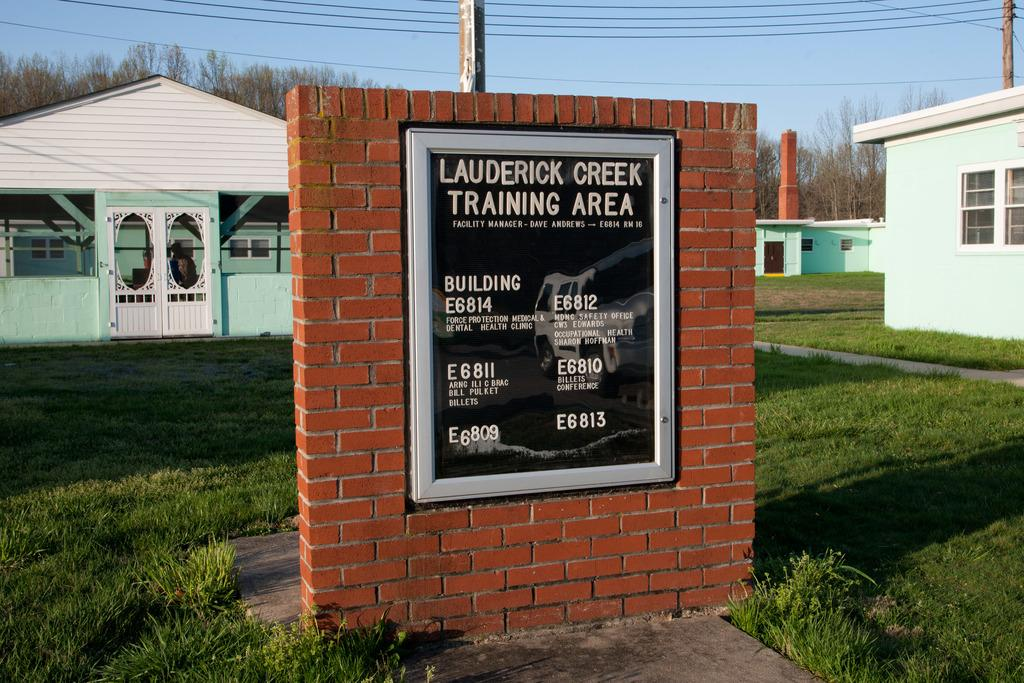What type of structure is present in the image? There is a brick wall in the image. What is attached to the brick wall? There is a frame attached to the brick wall. What type of buildings can be seen in the image? There are houses visible in the image. What type of vegetation is present in the image? There is a tree, plants, and grass visible in the image. Who is the creator of the cannon visible in the image? There is no cannon present in the image. What type of plough is being used to cultivate the grass in the image? There is no plough visible in the image; it features grass and other vegetation. 